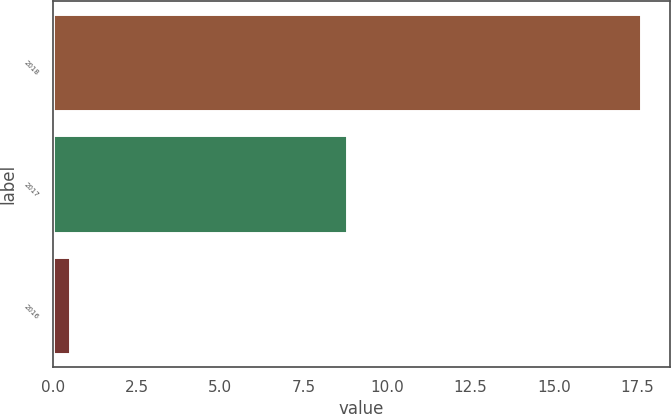Convert chart to OTSL. <chart><loc_0><loc_0><loc_500><loc_500><bar_chart><fcel>2018<fcel>2017<fcel>2016<nl><fcel>17.6<fcel>8.8<fcel>0.5<nl></chart> 